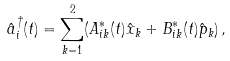Convert formula to latex. <formula><loc_0><loc_0><loc_500><loc_500>\hat { a } ^ { \dagger } _ { i } ( t ) = \sum _ { k = 1 } ^ { 2 } ( A ^ { \ast } _ { i k } ( t ) \hat { x } _ { k } + B ^ { \ast } _ { i k } ( t ) \hat { p } _ { k } ) \, ,</formula> 